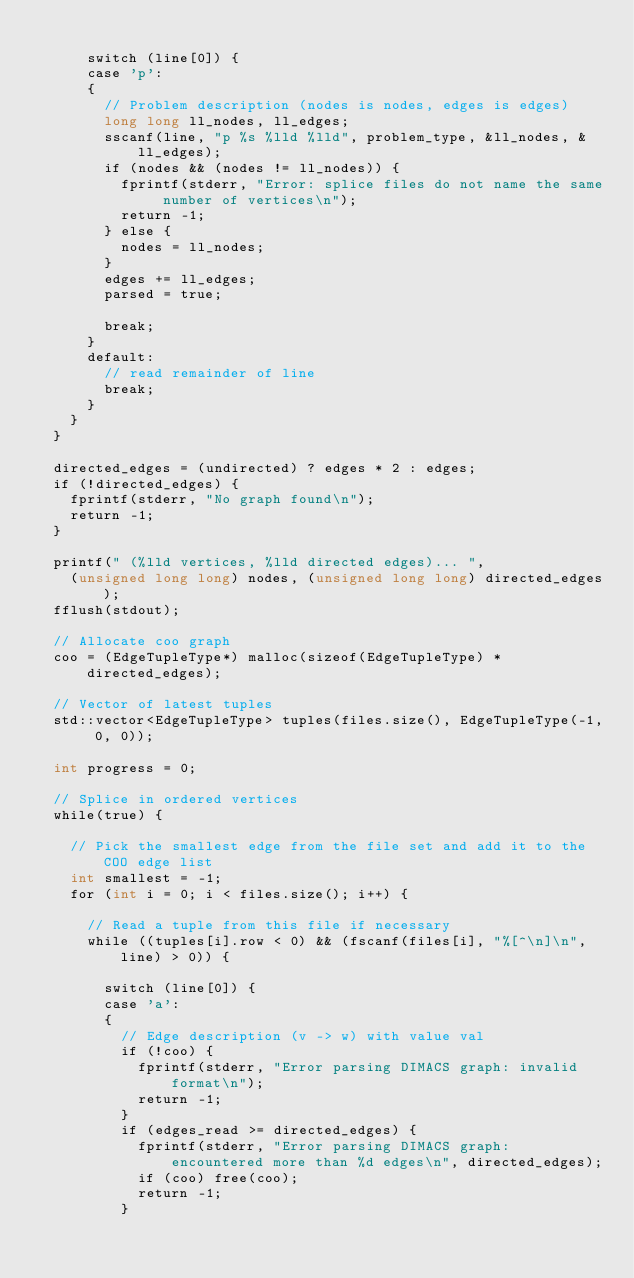<code> <loc_0><loc_0><loc_500><loc_500><_Cuda_>
			switch (line[0]) {
			case 'p':
			{
				// Problem description (nodes is nodes, edges is edges)
				long long ll_nodes, ll_edges;
				sscanf(line, "p %s %lld %lld", problem_type, &ll_nodes, &ll_edges);
				if (nodes && (nodes != ll_nodes)) {
					fprintf(stderr, "Error: splice files do not name the same number of vertices\n");
					return -1;
				} else {
					nodes = ll_nodes;
				}
				edges += ll_edges;
				parsed = true;

				break;
			}
			default:
				// read remainder of line
				break;
			}
		}
	}

	directed_edges = (undirected) ? edges * 2 : edges;
	if (!directed_edges) {
		fprintf(stderr, "No graph found\n");
		return -1;
	}

	printf(" (%lld vertices, %lld directed edges)... ",
		(unsigned long long) nodes, (unsigned long long) directed_edges);
	fflush(stdout);

	// Allocate coo graph
	coo = (EdgeTupleType*) malloc(sizeof(EdgeTupleType) * directed_edges);

	// Vector of latest tuples
	std::vector<EdgeTupleType> tuples(files.size(), EdgeTupleType(-1, 0, 0));

	int progress = 0;

	// Splice in ordered vertices
	while(true) {

		// Pick the smallest edge from the file set and add it to the COO edge list
		int smallest = -1;
		for (int i = 0; i < files.size(); i++) {
			
			// Read a tuple from this file if necessary
			while ((tuples[i].row < 0) && (fscanf(files[i], "%[^\n]\n", line) > 0)) {

				switch (line[0]) {
				case 'a':
				{
					// Edge description (v -> w) with value val
					if (!coo) {
						fprintf(stderr, "Error parsing DIMACS graph: invalid format\n");
						return -1;
					}
					if (edges_read >= directed_edges) {
						fprintf(stderr, "Error parsing DIMACS graph: encountered more than %d edges\n", directed_edges);
						if (coo) free(coo);
						return -1;
					}
</code> 